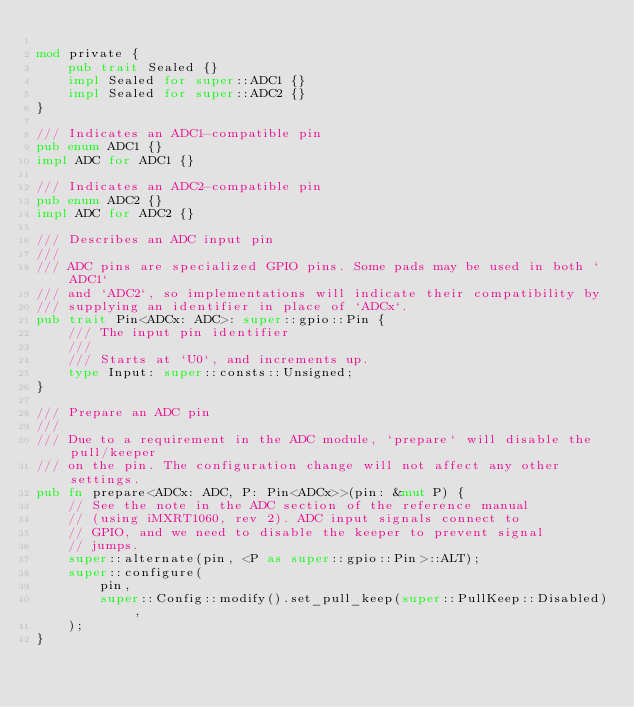Convert code to text. <code><loc_0><loc_0><loc_500><loc_500><_Rust_>
mod private {
    pub trait Sealed {}
    impl Sealed for super::ADC1 {}
    impl Sealed for super::ADC2 {}
}

/// Indicates an ADC1-compatible pin
pub enum ADC1 {}
impl ADC for ADC1 {}

/// Indicates an ADC2-compatible pin
pub enum ADC2 {}
impl ADC for ADC2 {}

/// Describes an ADC input pin
///
/// ADC pins are specialized GPIO pins. Some pads may be used in both `ADC1`
/// and `ADC2`, so implementations will indicate their compatibility by
/// supplying an identifier in place of `ADCx`.
pub trait Pin<ADCx: ADC>: super::gpio::Pin {
    /// The input pin identifier
    ///
    /// Starts at `U0`, and increments up.
    type Input: super::consts::Unsigned;
}

/// Prepare an ADC pin
///
/// Due to a requirement in the ADC module, `prepare` will disable the pull/keeper
/// on the pin. The configuration change will not affect any other settings.
pub fn prepare<ADCx: ADC, P: Pin<ADCx>>(pin: &mut P) {
    // See the note in the ADC section of the reference manual
    // (using iMXRT1060, rev 2). ADC input signals connect to
    // GPIO, and we need to disable the keeper to prevent signal
    // jumps.
    super::alternate(pin, <P as super::gpio::Pin>::ALT);
    super::configure(
        pin,
        super::Config::modify().set_pull_keep(super::PullKeep::Disabled),
    );
}
</code> 